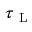Convert formula to latex. <formula><loc_0><loc_0><loc_500><loc_500>\tau _ { L }</formula> 